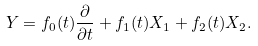Convert formula to latex. <formula><loc_0><loc_0><loc_500><loc_500>Y = f _ { 0 } ( t ) \frac { \partial } { \partial t } + f _ { 1 } ( t ) X _ { 1 } + f _ { 2 } ( t ) X _ { 2 } .</formula> 